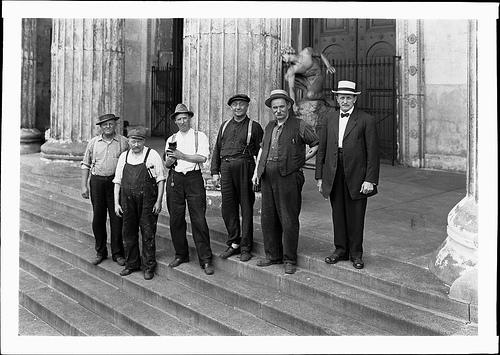Is there a bike in the picture?
Keep it brief. No. Where is the statue?
Answer briefly. Behind men. Where are these males?
Short answer required. Outside. How many men are there?
Short answer required. 6. Is this an old picture?
Be succinct. Yes. Are there more neckties or bow ties?
Quick response, please. Bow ties. What is the boy doing?
Short answer required. Standing. What year is this from?
Keep it brief. 1946. 